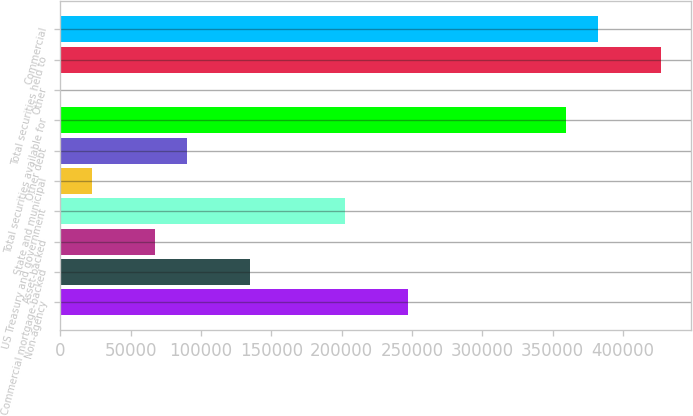Convert chart. <chart><loc_0><loc_0><loc_500><loc_500><bar_chart><fcel>Non-agency<fcel>Commercial mortgage-backed<fcel>Asset-backed<fcel>US Treasury and government<fcel>State and municipal<fcel>Other debt<fcel>Total securities available for<fcel>Other<fcel>Total securities held to<fcel>Commercial<nl><fcel>247220<fcel>134866<fcel>67453.4<fcel>202278<fcel>22511.8<fcel>89924.2<fcel>359574<fcel>41<fcel>426986<fcel>382045<nl></chart> 